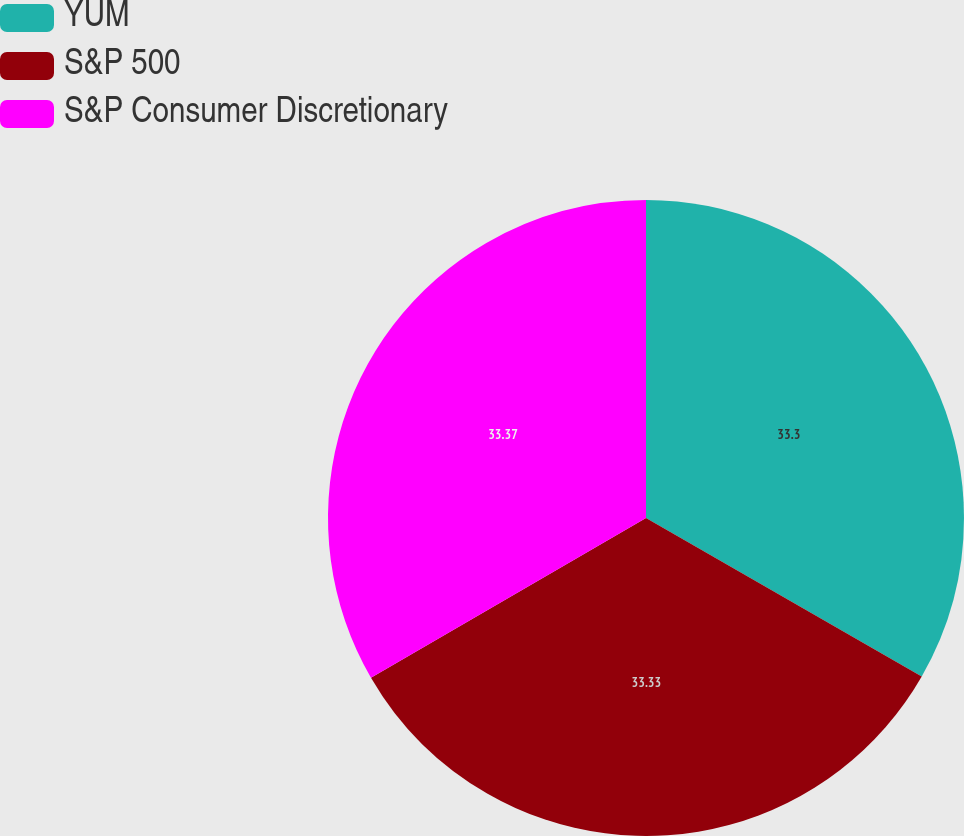<chart> <loc_0><loc_0><loc_500><loc_500><pie_chart><fcel>YUM<fcel>S&P 500<fcel>S&P Consumer Discretionary<nl><fcel>33.3%<fcel>33.33%<fcel>33.37%<nl></chart> 